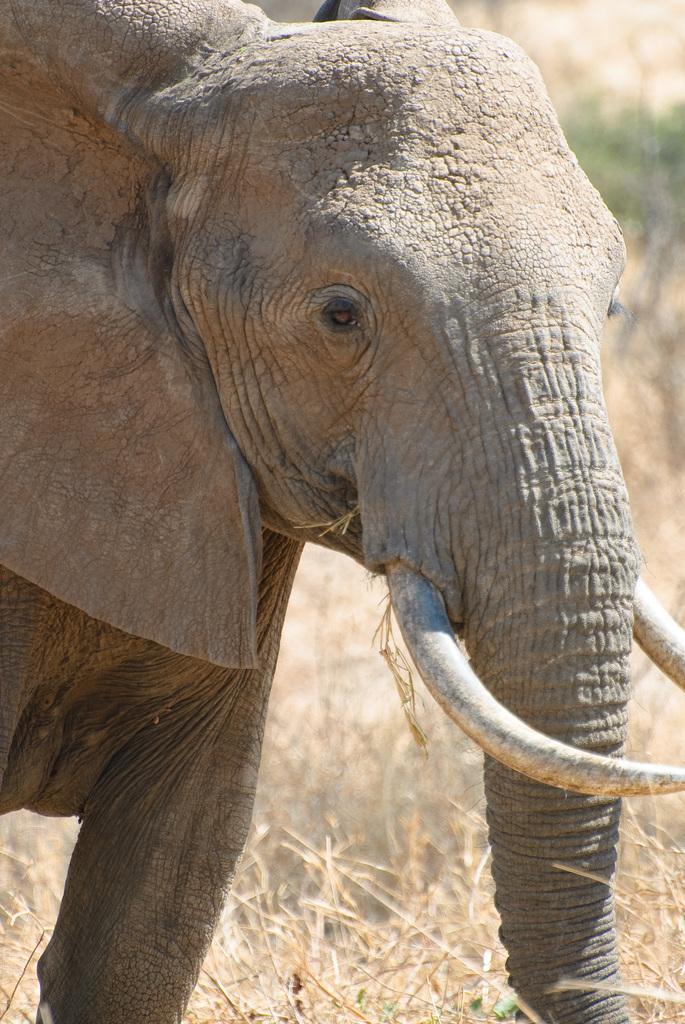How would you summarize this image in a sentence or two? In this image we can see an elephant. At the bottom there is grass. 